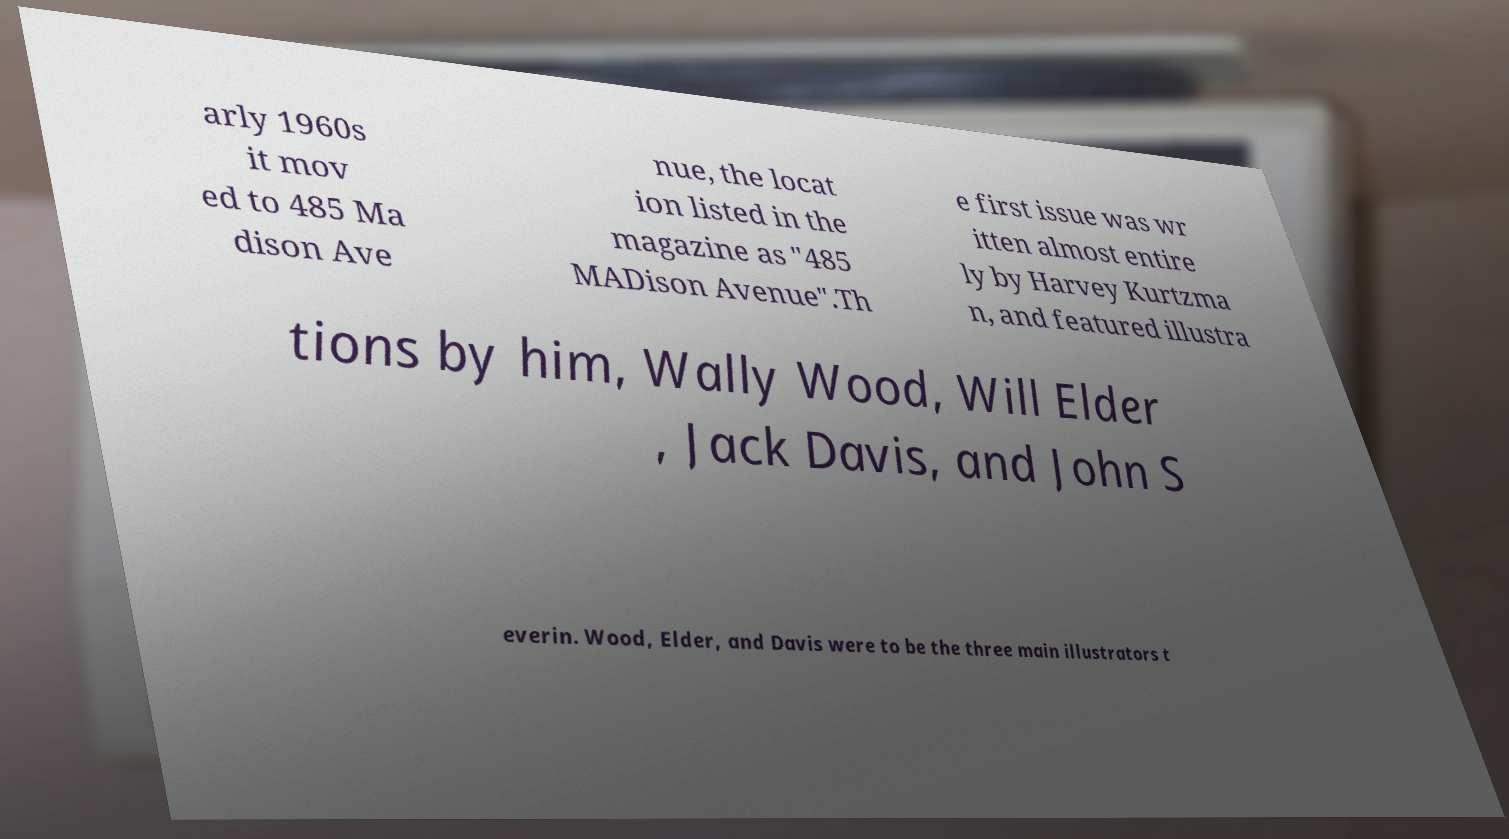There's text embedded in this image that I need extracted. Can you transcribe it verbatim? arly 1960s it mov ed to 485 Ma dison Ave nue, the locat ion listed in the magazine as "485 MADison Avenue".Th e first issue was wr itten almost entire ly by Harvey Kurtzma n, and featured illustra tions by him, Wally Wood, Will Elder , Jack Davis, and John S everin. Wood, Elder, and Davis were to be the three main illustrators t 